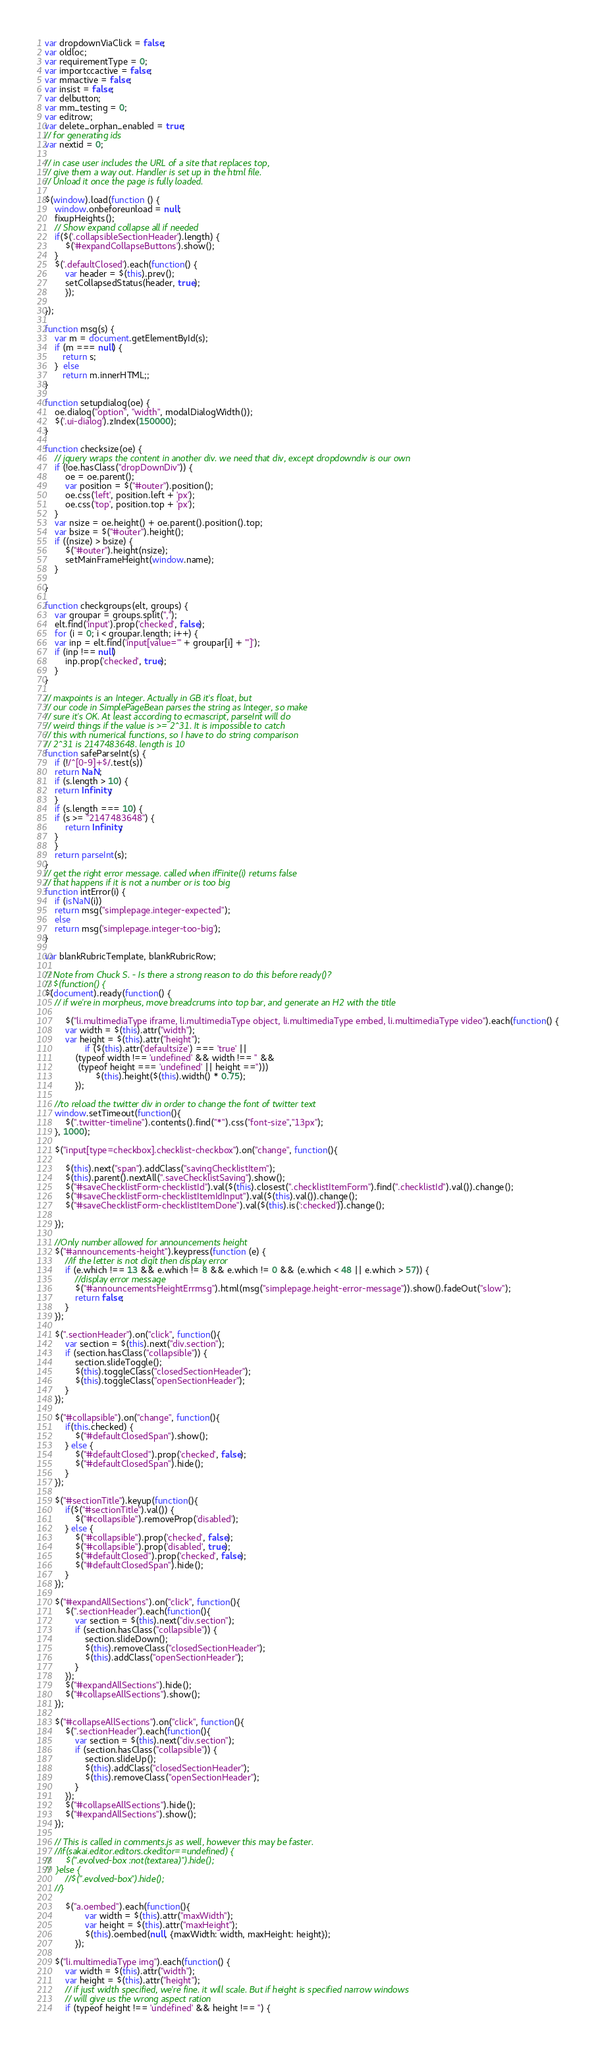<code> <loc_0><loc_0><loc_500><loc_500><_JavaScript_>var dropdownViaClick = false;
var oldloc;
var requirementType = 0;
var importccactive = false;
var mmactive = false;
var insist = false;
var delbutton;
var mm_testing = 0;
var editrow;
var delete_orphan_enabled = true;
// for generating ids
var nextid = 0;

// in case user includes the URL of a site that replaces top,
// give them a way out. Handler is set up in the html file.
// Unload it once the page is fully loaded.

$(window).load(function () {
	window.onbeforeunload = null;
	fixupHeights();
	// Show expand collapse all if needed
	if($('.collapsibleSectionHeader').length) {
		$('#expandCollapseButtons').show();
	}
	$('.defaultClosed').each(function() {
		var header = $(this).prev();
		setCollapsedStatus(header, true);
	    });

});

function msg(s) {
    var m = document.getElementById(s);
    if (m === null) {
       return s;
    }  else 
       return m.innerHTML;;
}

function setupdialog(oe) {
	oe.dialog("option", "width", modalDialogWidth());
	$('.ui-dialog').zIndex(150000);
}

function checksize(oe) {
    // jquery wraps the content in another div. we need that div, except dropdowndiv is our own
	if (!oe.hasClass("dropDownDiv")) {
		oe = oe.parent();
		var position = $("#outer").position();
		oe.css('left', position.left + 'px');
		oe.css('top', position.top + 'px');
	}
	var nsize = oe.height() + oe.parent().position().top;
	var bsize = $("#outer").height();
	if ((nsize) > bsize) {
		$("#outer").height(nsize);
		setMainFrameHeight(window.name);
	}

}

function checkgroups(elt, groups) {
    var groupar = groups.split(",");
    elt.find('input').prop('checked', false);
    for (i = 0; i < groupar.length; i++) {
	var inp = elt.find('input[value="' + groupar[i] + '"]');
	if (inp !== null)
	    inp.prop('checked', true);
    }
}

// maxpoints is an Integer. Actually in GB it's float, but
// our code in SimplePageBean parses the string as Integer, so make
// sure it's OK. At least according to ecmascript, parseInt will do
// weird things if the value is >= 2^31. It is impossible to catch
// this with numerical functions, so I have to do string comparison
// 2^31 is 2147483648. length is 10
function safeParseInt(s) {
    if (!/^[0-9]+$/.test(s))
	return NaN;
    if (s.length > 10) {
	return Infinity;
    }
    if (s.length === 10) {
	if (s >= "2147483648") {
	    return Infinity;
	}
    }
    return parseInt(s);
}
// get the right error message. called when ifFinite(i) returns false
// that happens if it is not a number or is too big
function intError(i) {
    if (isNaN(i))
	return msg("simplepage.integer-expected");
    else
	return msg('simplepage.integer-too-big');
}

var blankRubricTemplate, blankRubricRow;

// Note from Chuck S. - Is there a strong reason to do this before ready()?
// $(function() {
$(document).ready(function() {
	// if we're in morpheus, move breadcrums into top bar, and generate an H2 with the title

        $("li.multimediaType iframe, li.multimediaType object, li.multimediaType embed, li.multimediaType video").each(function() {
		var width = $(this).attr("width");
		var height = $(this).attr("height");
                if ($(this).attr('defaultsize') === 'true' ||
		    (typeof width !== 'undefined' && width !== '' &&
		     (typeof height === 'undefined' || height =='')))
                    $(this).height($(this).width() * 0.75);
            });

	//to reload the twitter div in order to change the font of twitter text
	window.setTimeout(function(){
		$(".twitter-timeline").contents().find("*").css("font-size","13px");
	}, 1000);

	$("input[type=checkbox].checklist-checkbox").on("change", function(){

		$(this).next("span").addClass("savingChecklistItem");
		$(this).parent().nextAll(".saveChecklistSaving").show();
		$("#saveChecklistForm-checklistId").val($(this).closest(".checklistItemForm").find(".checklistId").val()).change();
		$("#saveChecklistForm-checklistItemIdInput").val($(this).val()).change();
		$("#saveChecklistForm-checklistItemDone").val($(this).is(':checked')).change();

	});

	//Only number allowed for announcements height
	$("#announcements-height").keypress(function (e) {
		//if the letter is not digit then display error
		if (e.which !== 13 && e.which != 8 && e.which != 0 && (e.which < 48 || e.which > 57)) {
			//display error message
			$("#announcementsHeightErrmsg").html(msg("simplepage.height-error-message")).show().fadeOut("slow");
			return false;
		}
	});

	$(".sectionHeader").on("click", function(){
		var section = $(this).next("div.section");
		if (section.hasClass("collapsible")) {
			section.slideToggle();
			$(this).toggleClass("closedSectionHeader");
			$(this).toggleClass("openSectionHeader");
		}
	});

	$("#collapsible").on("change", function(){
		if(this.checked) {
			$("#defaultClosedSpan").show();
		} else {
			$("#defaultClosed").prop('checked', false);
			$("#defaultClosedSpan").hide();
		}
	});

	$("#sectionTitle").keyup(function(){
		if($("#sectionTitle").val()) {
			$("#collapsible").removeProp('disabled');
		} else {
			$("#collapsible").prop('checked', false);
			$("#collapsible").prop('disabled', true);
			$("#defaultClosed").prop('checked', false);
			$("#defaultClosedSpan").hide();
		}
	});

	$("#expandAllSections").on("click", function(){
		$(".sectionHeader").each(function(){
			var section = $(this).next("div.section");
			if (section.hasClass("collapsible")) {
				section.slideDown();
				$(this).removeClass("closedSectionHeader");
				$(this).addClass("openSectionHeader");
			}
		});
		$("#expandAllSections").hide();
		$("#collapseAllSections").show();
	});

	$("#collapseAllSections").on("click", function(){
		$(".sectionHeader").each(function(){
			var section = $(this).next("div.section");
			if (section.hasClass("collapsible")) {
				section.slideUp();
				$(this).addClass("closedSectionHeader");
				$(this).removeClass("openSectionHeader");
			}
		});
		$("#collapseAllSections").hide();
		$("#expandAllSections").show();
	});

	// This is called in comments.js as well, however this may be faster.
	//if(sakai.editor.editors.ckeditor==undefined) {
//		$(".evolved-box :not(textarea)").hide();
//	}else {
		//$(".evolved-box").hide();
	//}

        $("a.oembed").each(function(){
                var width = $(this).attr("maxWidth");
                var height = $(this).attr("maxHeight");
                $(this).oembed(null, {maxWidth: width, maxHeight: height});
            });

	$("li.multimediaType img").each(function() {
		var width = $(this).attr("width");
		var height = $(this).attr("height");
		// if just width specified, we're fine. it will scale. But if height is specified narrow windows
		// will give us the wrong aspect ration
		if (typeof height !== 'undefined' && height !== '') {</code> 